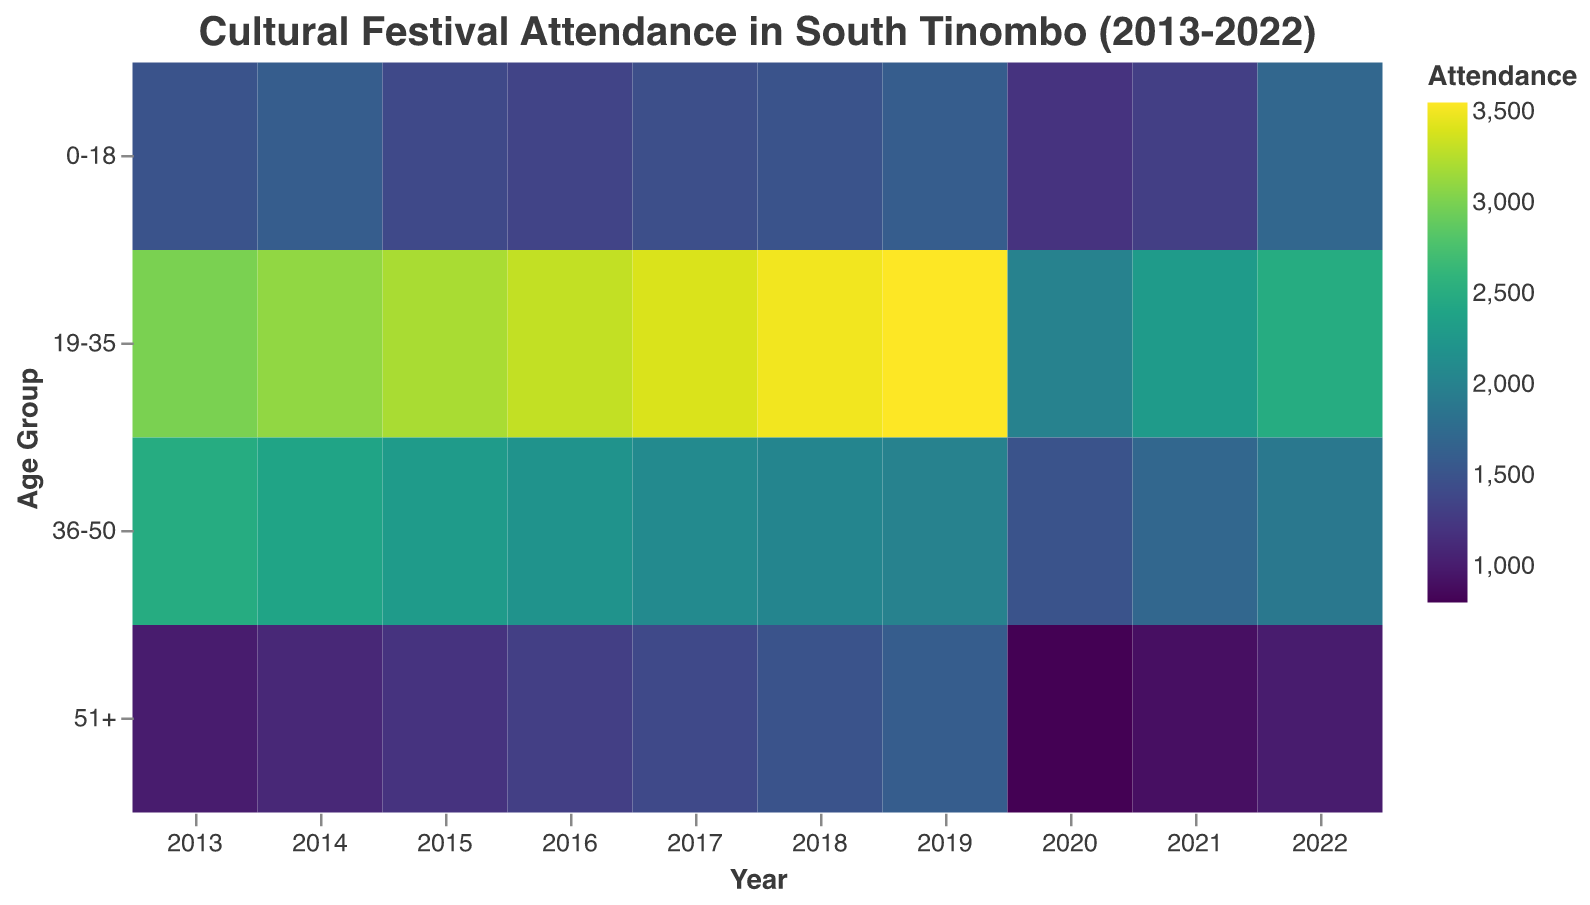What is the title of the heatmap? The title of the heatmap is usually found at the top of the plot and describes the data being visualized. Here, it mentions "Cultural Festival Attendance in South Tinombo (2013-2022)".
Answer: Cultural Festival Attendance in South Tinombo (2013-2022) What are the age groups shown in the heatmap? The age groups are typically listed along the y-axis. Here, they are "0-18", "19-35", "36-50", and "51+".
Answer: 0-18, 19-35, 36-50, 51+ Which year had the highest attendance in the 19-35 age group? To find the highest attendance for the 19-35 age group, look for the darkest area in the row corresponding to 19-35 and note the year. The darkest cell for the 19-35 age group is in the year 2019.
Answer: 2019 In which year did the 51+ age group have the lowest attendance? To identify the lowest attendance for the 51+ age group, look for the lightest cell in the row labeled 51+. The lightest cell is in the year 2020.
Answer: 2020 What trend can be observed in the attendance of the 0-18 age group over the years? Observing the 0-18 row, one can see that the attendance generally ranges from 1200 to 1700 over the years, indicating a slight fluctuation but an overall stability with a drop in 2020 followed by a recovery.
Answer: Slight fluctuation with drop in 2020, then recovery Compare the attendance change between 2019 and 2020 for all age groups. To compare, subtract the attendance figures for 2020 from those in 2019 for each age group: 0-18: 1600 - 1200 = 400, 19-35: 3550 - 2000 = 1550, 36-50: 2000 - 1500 = 500, 51+: 1600 - 800 = 800. Hence, in all age groups, attendance dropped significantly in 2020.
Answer: All age groups saw a significant drop What was the total attendance for all age groups in the year 2022? Add up the attendance figures for all age groups in 2022: 1700 (0-18) + 2500 (19-35) + 1900 (36-50) + 1000 (51+).
Answer: 7100 Which age group showed the most consistent attendance over the decade? By examining the variation in color for each age group over the years, the 0-18 age group shows relatively less fluctuation compared to others, indicating consistent attendance.
Answer: 0-18 What could be inferred regarding the impact of COVID-19 on festival attendance in 2020 and 2021? Noting the significant drops in attendance across all age groups in 2020 and partial recovery in 2021 but not to pre-2020 levels, it can be inferred that COVID-19 had a considerable negative impact on cultural festival attendance.
Answer: Significant negative impact 